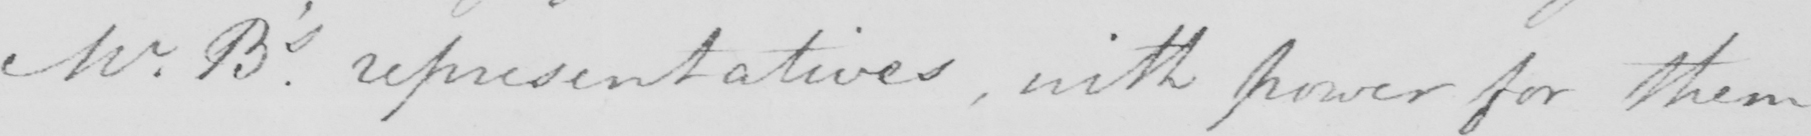Can you read and transcribe this handwriting? Mr . B ' s . representatives , with power for them 